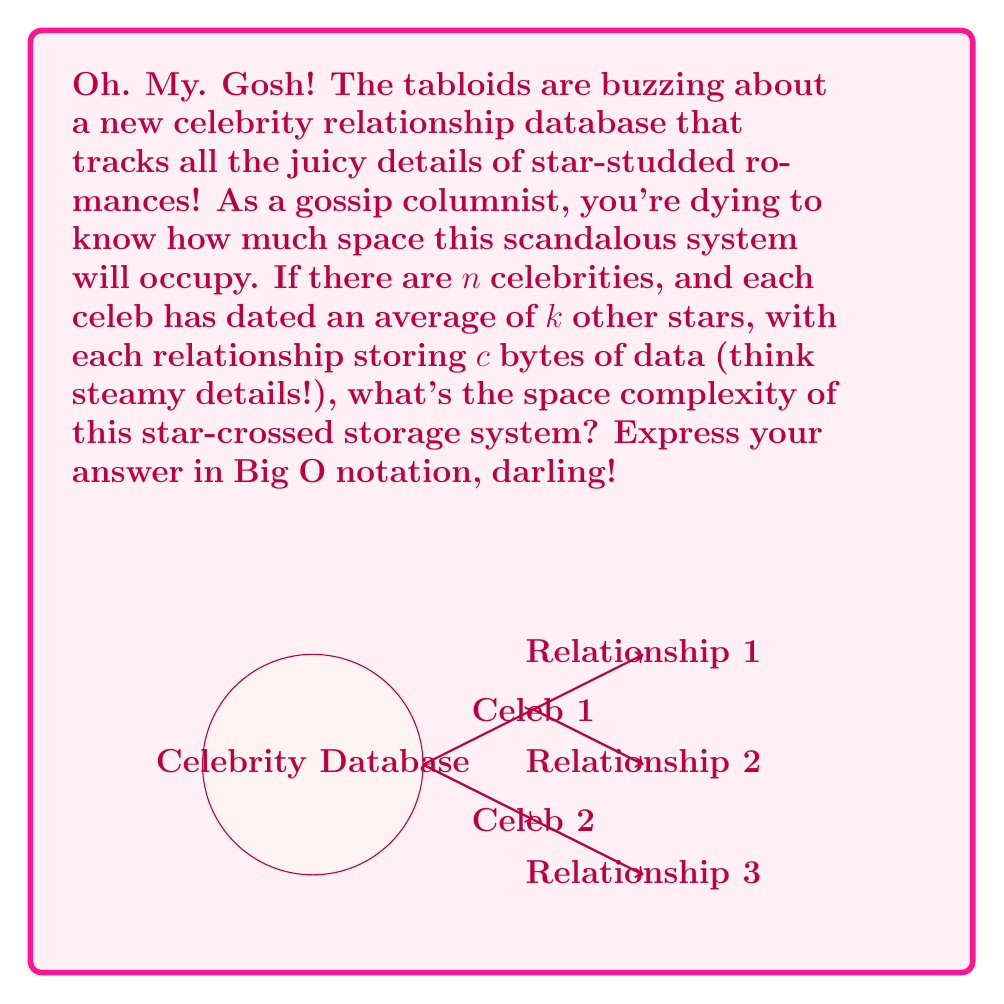Show me your answer to this math problem. Let's break this down step-by-step, darling:

1) First, we need to consider how many relationships we're storing in total:
   - There are $n$ celebrities
   - Each celebrity has dated an average of $k$ other stars
   - However, each relationship involves 2 celebrities, so we need to divide by 2 to avoid double-counting

   Total relationships = $\frac{n \cdot k}{2}$

2) Now, for each relationship, we're storing $c$ bytes of data:
   
   Total space for relationships = $\frac{n \cdot k \cdot c}{2}$

3) We also need to account for some basic information about each celebrity (like their name, etc.). Let's say this takes a constant amount of space, $d$, for each celebrity:

   Total space for celebrity info = $n \cdot d$

4) The total space used is the sum of these two components:

   Total space = $\frac{n \cdot k \cdot c}{2} + n \cdot d$
                = $n(\frac{k \cdot c}{2} + d)$

5) In Big O notation, we drop constant factors and lower-order terms. Both $k$, $c$, and $d$ are constants in this scenario.

6) Therefore, the space complexity simplifies to $O(n)$.

This means the space required grows linearly with the number of celebrities in our fabulously gossipy database!
Answer: $O(n)$ 